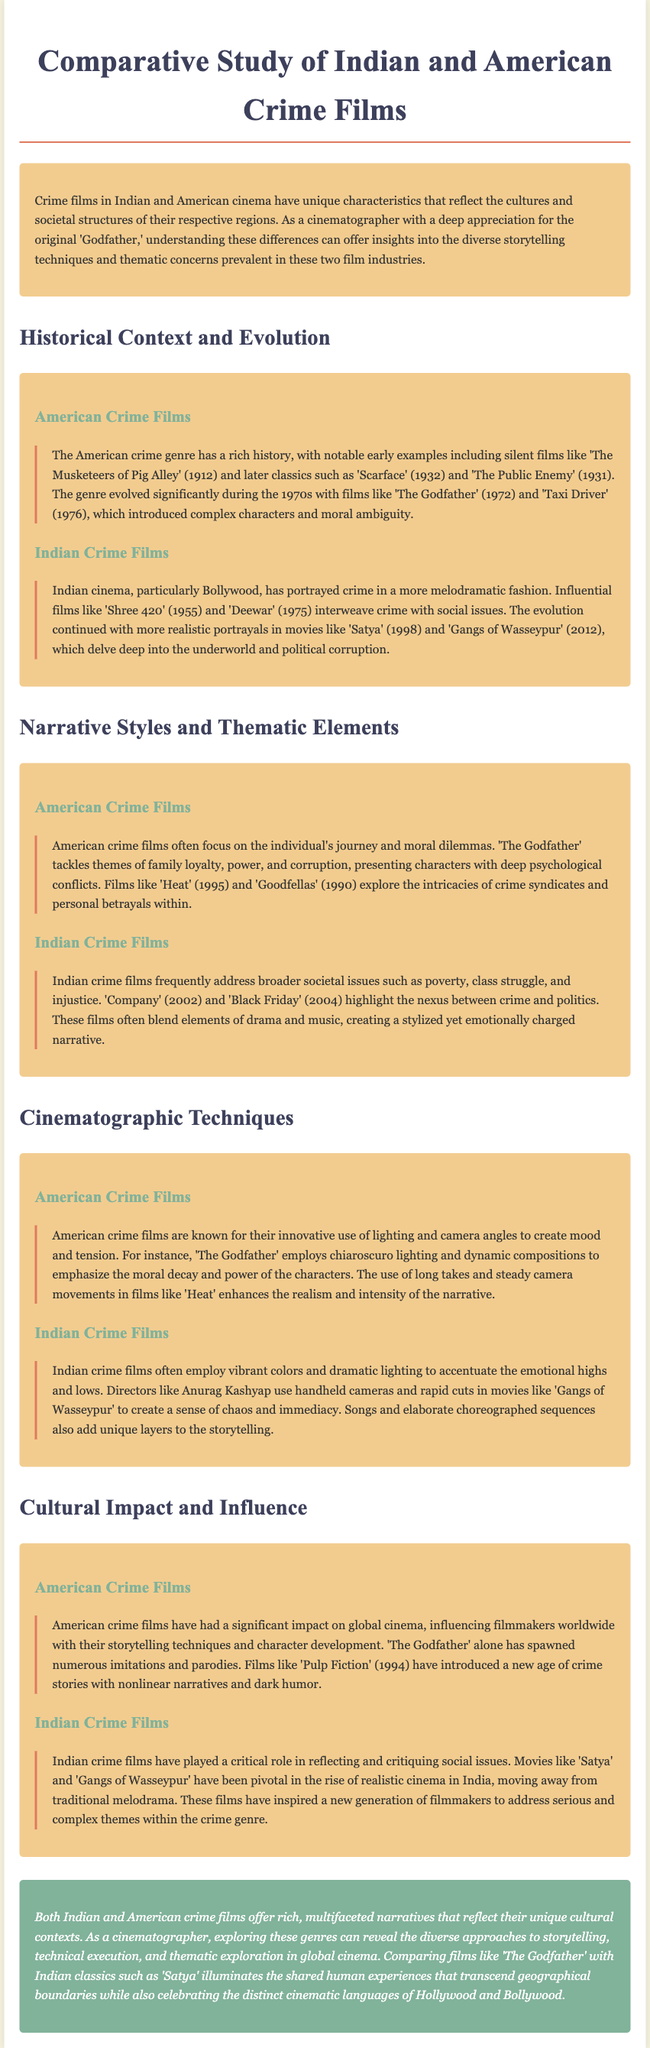What is the title of the document? The title of the document is provided in the header.
Answer: Comparative Study of Indian and American Crime Films What year was 'The Godfather' released? The document mentions the release year of 'The Godfather' in the context of American crime films.
Answer: 1972 Which film is noted for its portrayal of moral decay in American cinema? The document describes 'The Godfather' as showcasing moral decay.
Answer: The Godfather What societal issues do Indian crime films often address? The document lists broader societal issues highlighted in Indian crime films.
Answer: Poverty, class struggle, and injustice Which Indian film is highlighted for reflecting the nexus between crime and politics? The document identifies an Indian film that addresses the connection between crime and politics.
Answer: Company What cinematographic technique is common in American crime films as mentioned in the document? The document specifically discusses the use of lighting and camera angles in American crime films.
Answer: Chiaroscuro lighting What type of lighting technique do Indian crime films often use? The document states the use of certain dramatic lighting techniques in Indian films.
Answer: Vibrant colors Which director is mentioned in reference to 'Gangs of Wasseypur'? The document names a director associated with 'Gangs of Wasseypur.'
Answer: Anurag Kashyap What has been a critical role of Indian crime films according to the document? The document asserts that Indian crime films play a crucial role in reflecting and critiquing certain aspects.
Answer: Reflecting and critiquing social issues 